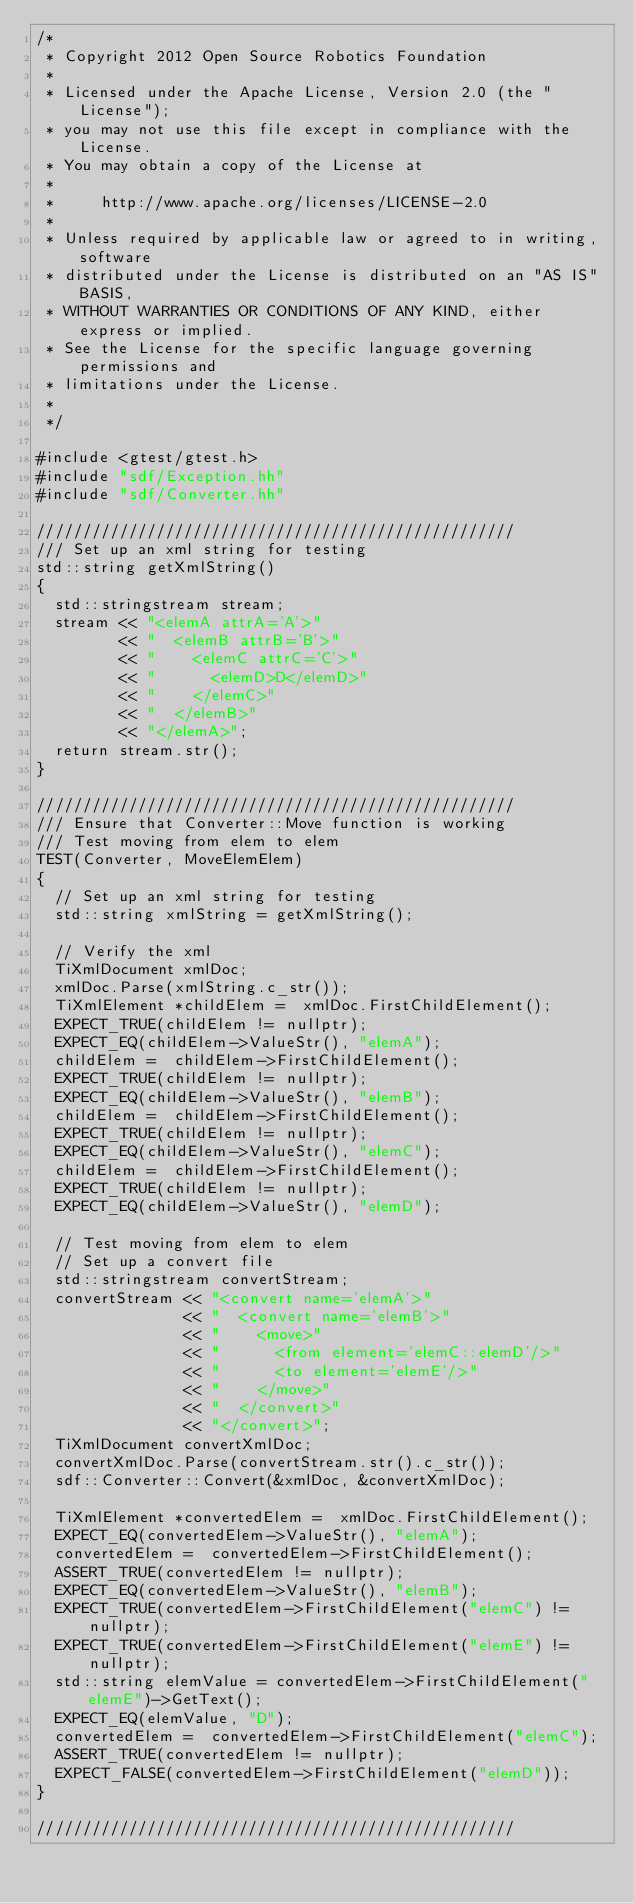<code> <loc_0><loc_0><loc_500><loc_500><_C++_>/*
 * Copyright 2012 Open Source Robotics Foundation
 *
 * Licensed under the Apache License, Version 2.0 (the "License");
 * you may not use this file except in compliance with the License.
 * You may obtain a copy of the License at
 *
 *     http://www.apache.org/licenses/LICENSE-2.0
 *
 * Unless required by applicable law or agreed to in writing, software
 * distributed under the License is distributed on an "AS IS" BASIS,
 * WITHOUT WARRANTIES OR CONDITIONS OF ANY KIND, either express or implied.
 * See the License for the specific language governing permissions and
 * limitations under the License.
 *
 */

#include <gtest/gtest.h>
#include "sdf/Exception.hh"
#include "sdf/Converter.hh"

////////////////////////////////////////////////////
/// Set up an xml string for testing
std::string getXmlString()
{
  std::stringstream stream;
  stream << "<elemA attrA='A'>"
         << "  <elemB attrB='B'>"
         << "    <elemC attrC='C'>"
         << "      <elemD>D</elemD>"
         << "    </elemC>"
         << "  </elemB>"
         << "</elemA>";
  return stream.str();
}

////////////////////////////////////////////////////
/// Ensure that Converter::Move function is working
/// Test moving from elem to elem
TEST(Converter, MoveElemElem)
{
  // Set up an xml string for testing
  std::string xmlString = getXmlString();

  // Verify the xml
  TiXmlDocument xmlDoc;
  xmlDoc.Parse(xmlString.c_str());
  TiXmlElement *childElem =  xmlDoc.FirstChildElement();
  EXPECT_TRUE(childElem != nullptr);
  EXPECT_EQ(childElem->ValueStr(), "elemA");
  childElem =  childElem->FirstChildElement();
  EXPECT_TRUE(childElem != nullptr);
  EXPECT_EQ(childElem->ValueStr(), "elemB");
  childElem =  childElem->FirstChildElement();
  EXPECT_TRUE(childElem != nullptr);
  EXPECT_EQ(childElem->ValueStr(), "elemC");
  childElem =  childElem->FirstChildElement();
  EXPECT_TRUE(childElem != nullptr);
  EXPECT_EQ(childElem->ValueStr(), "elemD");

  // Test moving from elem to elem
  // Set up a convert file
  std::stringstream convertStream;
  convertStream << "<convert name='elemA'>"
                << "  <convert name='elemB'>"
                << "    <move>"
                << "      <from element='elemC::elemD'/>"
                << "      <to element='elemE'/>"
                << "    </move>"
                << "  </convert>"
                << "</convert>";
  TiXmlDocument convertXmlDoc;
  convertXmlDoc.Parse(convertStream.str().c_str());
  sdf::Converter::Convert(&xmlDoc, &convertXmlDoc);

  TiXmlElement *convertedElem =  xmlDoc.FirstChildElement();
  EXPECT_EQ(convertedElem->ValueStr(), "elemA");
  convertedElem =  convertedElem->FirstChildElement();
  ASSERT_TRUE(convertedElem != nullptr);
  EXPECT_EQ(convertedElem->ValueStr(), "elemB");
  EXPECT_TRUE(convertedElem->FirstChildElement("elemC") != nullptr);
  EXPECT_TRUE(convertedElem->FirstChildElement("elemE") != nullptr);
  std::string elemValue = convertedElem->FirstChildElement("elemE")->GetText();
  EXPECT_EQ(elemValue, "D");
  convertedElem =  convertedElem->FirstChildElement("elemC");
  ASSERT_TRUE(convertedElem != nullptr);
  EXPECT_FALSE(convertedElem->FirstChildElement("elemD"));
}

////////////////////////////////////////////////////</code> 